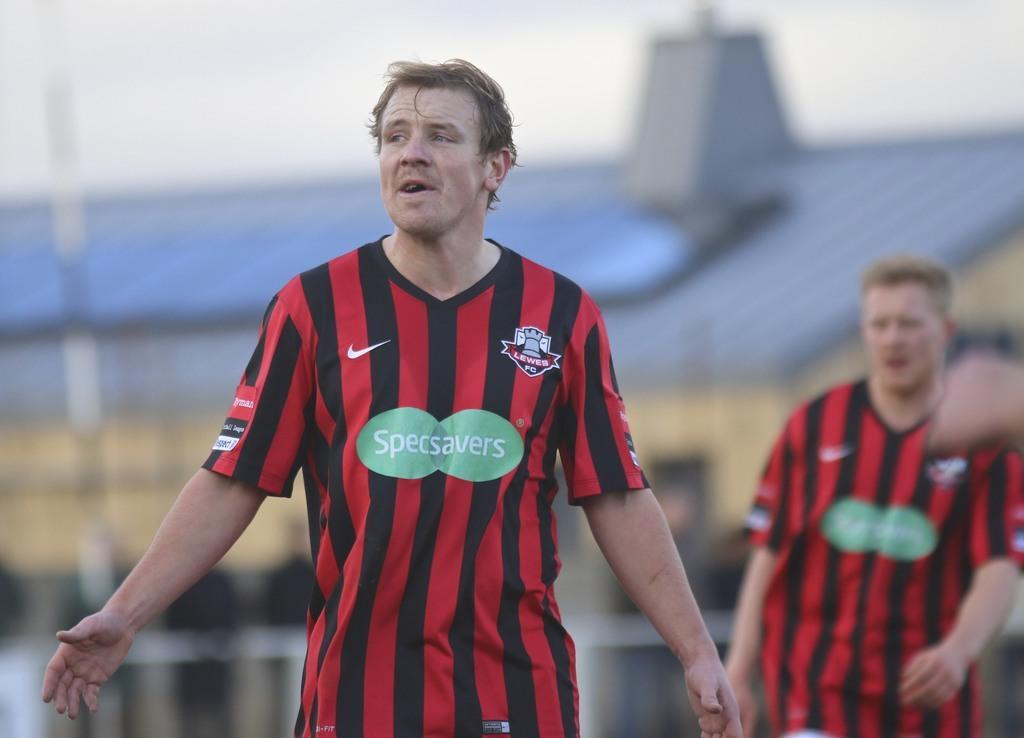In one or two sentences, can you explain what this image depicts? This picture is clicked outside. In the foreground we can see the two persons wearing red color t-shirts and seems to be walking on the ground and we can see the text on the t-shirts. In the background there is a sky and we can see the house with a blue roof top and we can see some other objects in the background. 